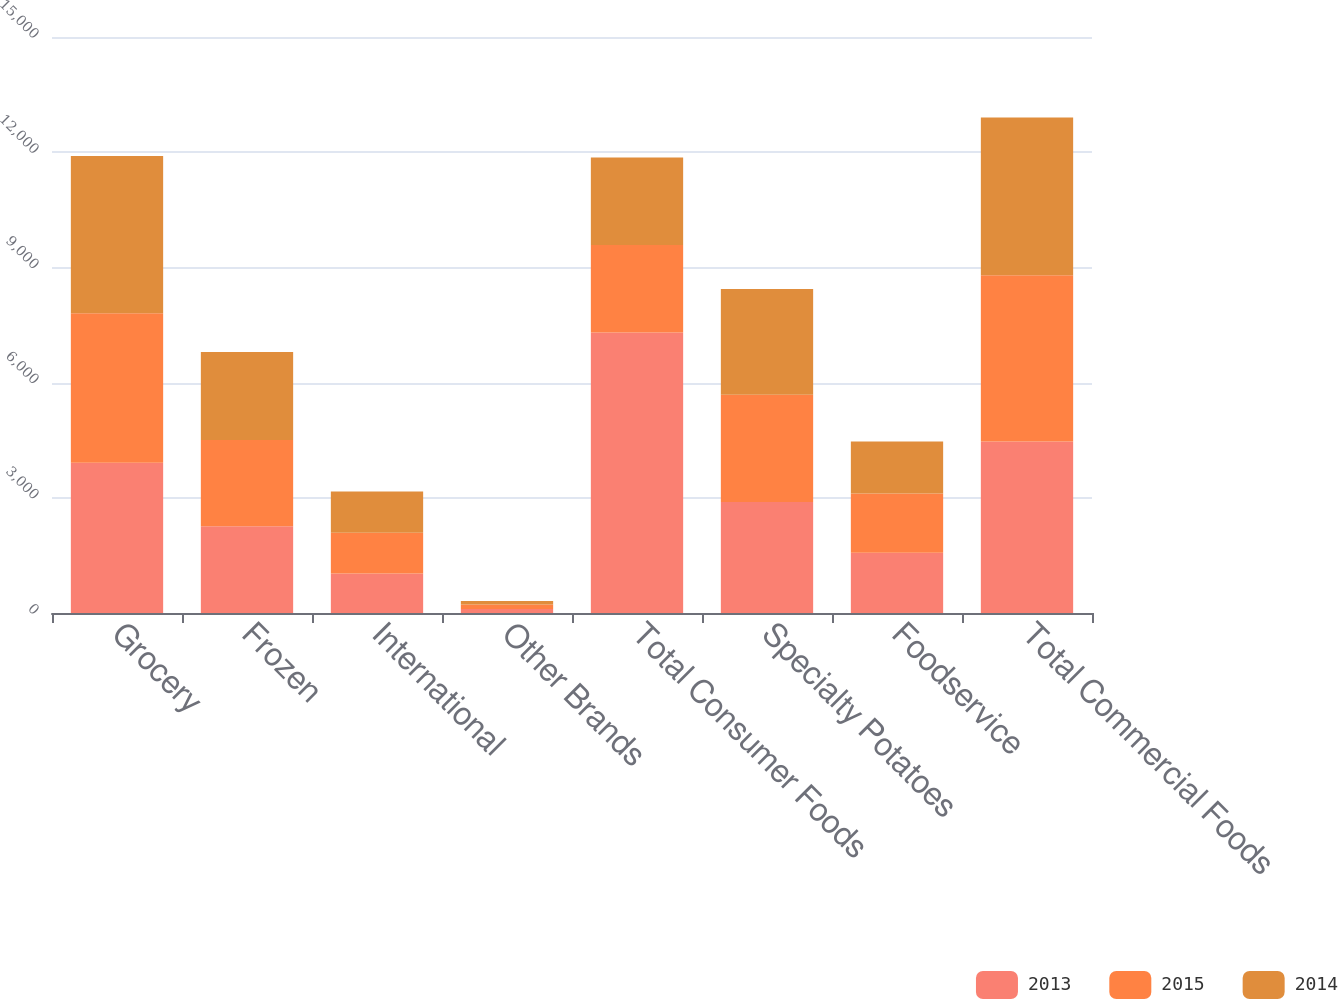Convert chart to OTSL. <chart><loc_0><loc_0><loc_500><loc_500><stacked_bar_chart><ecel><fcel>Grocery<fcel>Frozen<fcel>International<fcel>Other Brands<fcel>Total Consumer Foods<fcel>Specialty Potatoes<fcel>Foodservice<fcel>Total Commercial Foods<nl><fcel>2013<fcel>3911.1<fcel>2261.9<fcel>1026.1<fcel>105.3<fcel>7304.4<fcel>2892.4<fcel>1570.8<fcel>4463.2<nl><fcel>2015<fcel>3897<fcel>2241.9<fcel>1061.4<fcel>115.4<fcel>2278.7<fcel>2792.7<fcel>1539.5<fcel>4332.2<nl><fcel>2014<fcel>4093.4<fcel>2295.5<fcel>1073.7<fcel>88.8<fcel>2278.7<fcel>2753.1<fcel>1356.6<fcel>4109.7<nl></chart> 